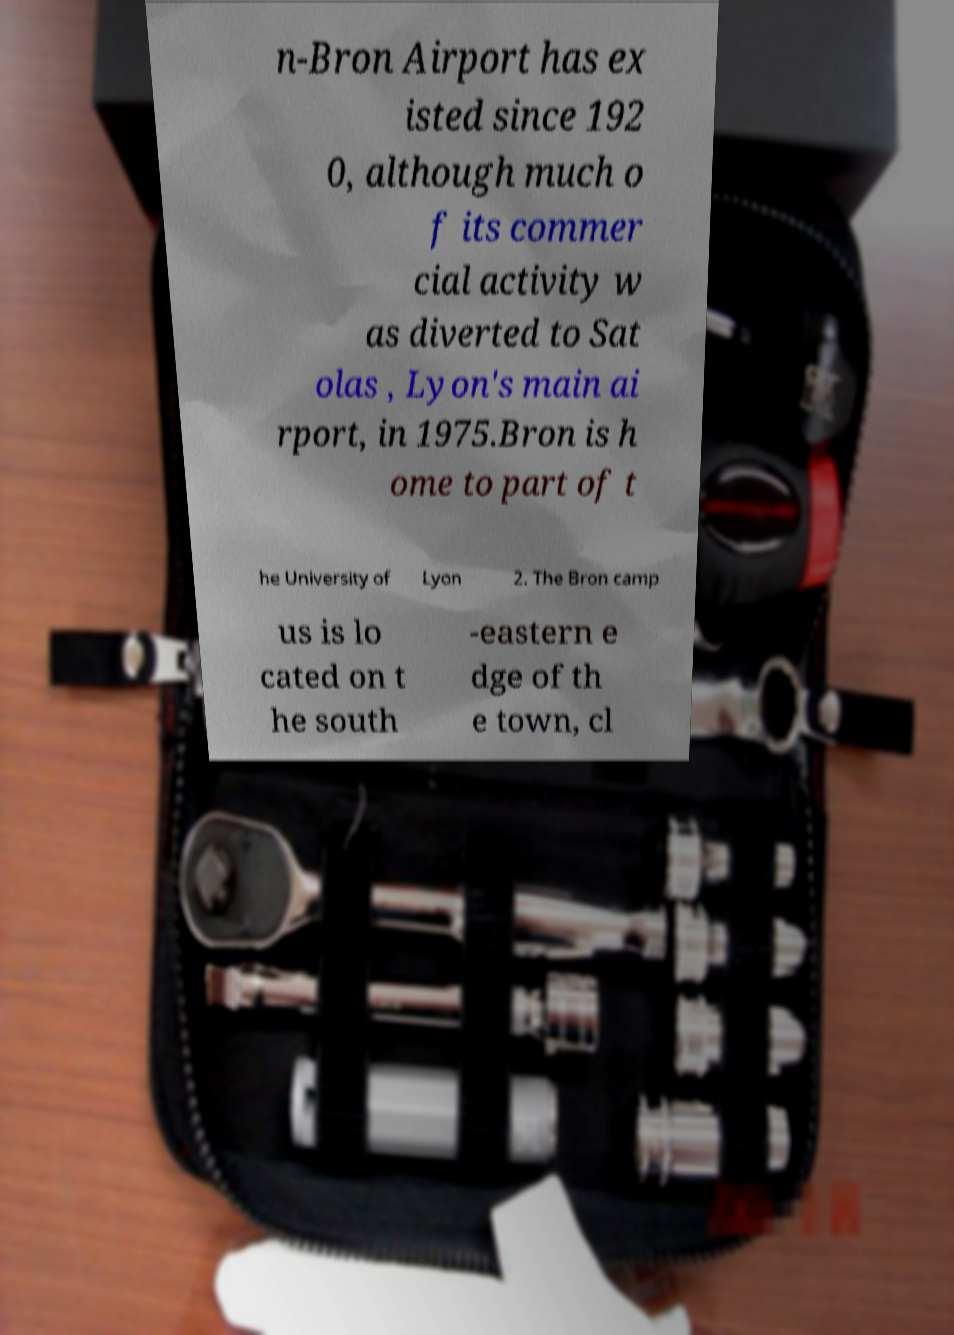Please read and relay the text visible in this image. What does it say? n-Bron Airport has ex isted since 192 0, although much o f its commer cial activity w as diverted to Sat olas , Lyon's main ai rport, in 1975.Bron is h ome to part of t he University of Lyon 2. The Bron camp us is lo cated on t he south -eastern e dge of th e town, cl 